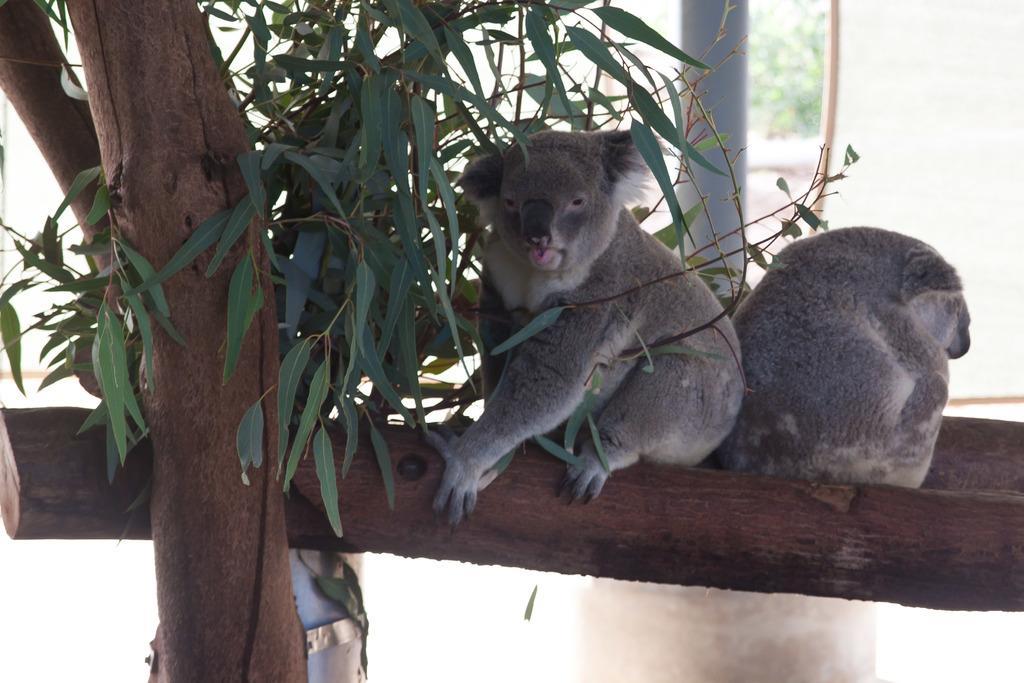How would you summarize this image in a sentence or two? In this picture we can see animals on a tree branch, leaves and in the background we can see a pole, trees and it is blurry. 